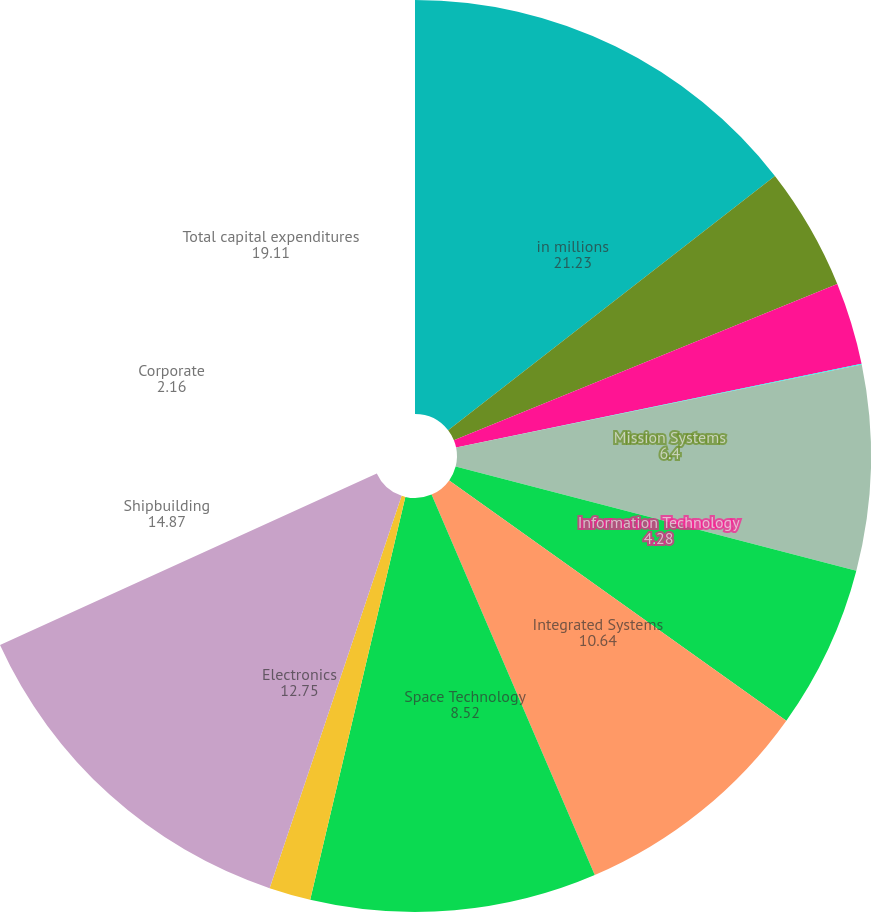Convert chart to OTSL. <chart><loc_0><loc_0><loc_500><loc_500><pie_chart><fcel>in millions<fcel>Mission Systems<fcel>Information Technology<fcel>Technical Services<fcel>Integrated Systems<fcel>Space Technology<fcel>Electronics<fcel>Shipbuilding<fcel>Corporate<fcel>Total capital expenditures<nl><fcel>21.23%<fcel>6.4%<fcel>4.28%<fcel>0.04%<fcel>10.64%<fcel>8.52%<fcel>12.75%<fcel>14.87%<fcel>2.16%<fcel>19.11%<nl></chart> 